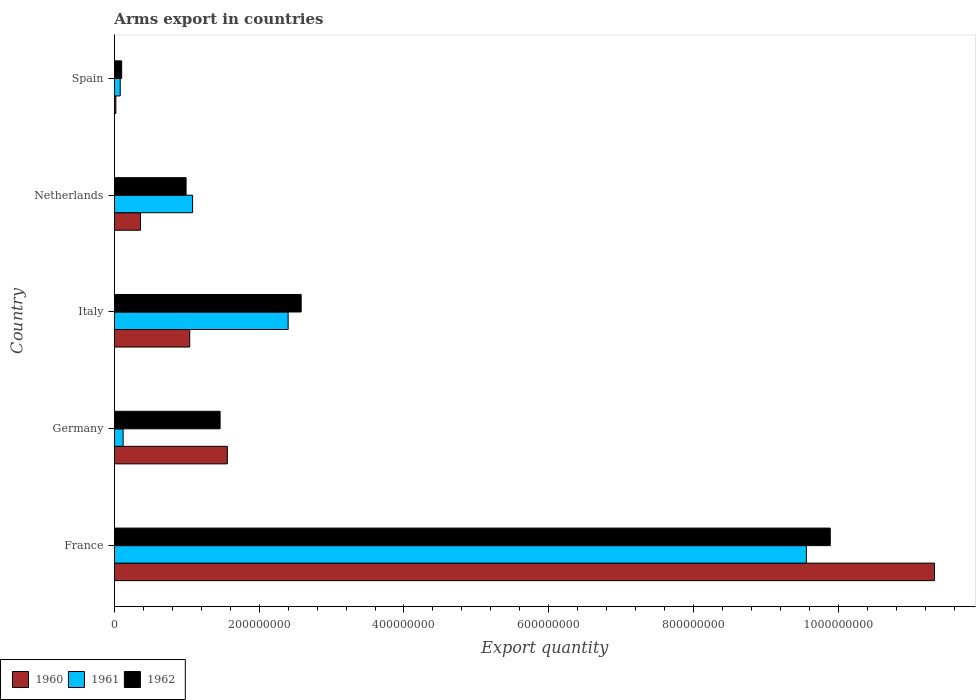How many groups of bars are there?
Give a very brief answer. 5. How many bars are there on the 1st tick from the top?
Provide a succinct answer. 3. How many bars are there on the 1st tick from the bottom?
Provide a succinct answer. 3. In how many cases, is the number of bars for a given country not equal to the number of legend labels?
Provide a short and direct response. 0. What is the total arms export in 1960 in Germany?
Your answer should be compact. 1.56e+08. Across all countries, what is the maximum total arms export in 1961?
Provide a short and direct response. 9.56e+08. In which country was the total arms export in 1960 maximum?
Ensure brevity in your answer.  France. What is the total total arms export in 1961 in the graph?
Offer a very short reply. 1.32e+09. What is the difference between the total arms export in 1961 in France and that in Spain?
Your answer should be compact. 9.48e+08. What is the difference between the total arms export in 1961 in Spain and the total arms export in 1960 in Netherlands?
Provide a succinct answer. -2.80e+07. What is the average total arms export in 1962 per country?
Provide a short and direct response. 3.00e+08. What is the difference between the total arms export in 1961 and total arms export in 1962 in France?
Provide a succinct answer. -3.30e+07. In how many countries, is the total arms export in 1960 greater than 840000000 ?
Your response must be concise. 1. What is the ratio of the total arms export in 1960 in Italy to that in Netherlands?
Your answer should be very brief. 2.89. Is the difference between the total arms export in 1961 in Germany and Spain greater than the difference between the total arms export in 1962 in Germany and Spain?
Offer a very short reply. No. What is the difference between the highest and the second highest total arms export in 1961?
Make the answer very short. 7.16e+08. What is the difference between the highest and the lowest total arms export in 1962?
Your answer should be compact. 9.79e+08. In how many countries, is the total arms export in 1962 greater than the average total arms export in 1962 taken over all countries?
Provide a short and direct response. 1. What does the 2nd bar from the bottom in Germany represents?
Keep it short and to the point. 1961. Is it the case that in every country, the sum of the total arms export in 1962 and total arms export in 1961 is greater than the total arms export in 1960?
Ensure brevity in your answer.  Yes. Are all the bars in the graph horizontal?
Your answer should be compact. Yes. What is the difference between two consecutive major ticks on the X-axis?
Provide a succinct answer. 2.00e+08. Are the values on the major ticks of X-axis written in scientific E-notation?
Keep it short and to the point. No. Where does the legend appear in the graph?
Your answer should be compact. Bottom left. What is the title of the graph?
Offer a very short reply. Arms export in countries. What is the label or title of the X-axis?
Keep it short and to the point. Export quantity. What is the label or title of the Y-axis?
Ensure brevity in your answer.  Country. What is the Export quantity in 1960 in France?
Offer a very short reply. 1.13e+09. What is the Export quantity of 1961 in France?
Make the answer very short. 9.56e+08. What is the Export quantity of 1962 in France?
Give a very brief answer. 9.89e+08. What is the Export quantity in 1960 in Germany?
Your response must be concise. 1.56e+08. What is the Export quantity in 1962 in Germany?
Provide a short and direct response. 1.46e+08. What is the Export quantity in 1960 in Italy?
Your answer should be compact. 1.04e+08. What is the Export quantity of 1961 in Italy?
Offer a terse response. 2.40e+08. What is the Export quantity of 1962 in Italy?
Provide a succinct answer. 2.58e+08. What is the Export quantity of 1960 in Netherlands?
Give a very brief answer. 3.60e+07. What is the Export quantity of 1961 in Netherlands?
Provide a succinct answer. 1.08e+08. What is the Export quantity of 1962 in Netherlands?
Give a very brief answer. 9.90e+07. What is the Export quantity in 1962 in Spain?
Your response must be concise. 1.00e+07. Across all countries, what is the maximum Export quantity of 1960?
Your response must be concise. 1.13e+09. Across all countries, what is the maximum Export quantity in 1961?
Give a very brief answer. 9.56e+08. Across all countries, what is the maximum Export quantity in 1962?
Give a very brief answer. 9.89e+08. Across all countries, what is the minimum Export quantity of 1960?
Your answer should be very brief. 2.00e+06. Across all countries, what is the minimum Export quantity in 1961?
Give a very brief answer. 8.00e+06. Across all countries, what is the minimum Export quantity of 1962?
Ensure brevity in your answer.  1.00e+07. What is the total Export quantity of 1960 in the graph?
Keep it short and to the point. 1.43e+09. What is the total Export quantity of 1961 in the graph?
Keep it short and to the point. 1.32e+09. What is the total Export quantity of 1962 in the graph?
Provide a short and direct response. 1.50e+09. What is the difference between the Export quantity in 1960 in France and that in Germany?
Give a very brief answer. 9.77e+08. What is the difference between the Export quantity in 1961 in France and that in Germany?
Give a very brief answer. 9.44e+08. What is the difference between the Export quantity in 1962 in France and that in Germany?
Ensure brevity in your answer.  8.43e+08. What is the difference between the Export quantity in 1960 in France and that in Italy?
Your answer should be very brief. 1.03e+09. What is the difference between the Export quantity in 1961 in France and that in Italy?
Your response must be concise. 7.16e+08. What is the difference between the Export quantity in 1962 in France and that in Italy?
Offer a terse response. 7.31e+08. What is the difference between the Export quantity of 1960 in France and that in Netherlands?
Offer a terse response. 1.10e+09. What is the difference between the Export quantity of 1961 in France and that in Netherlands?
Provide a short and direct response. 8.48e+08. What is the difference between the Export quantity of 1962 in France and that in Netherlands?
Your answer should be very brief. 8.90e+08. What is the difference between the Export quantity of 1960 in France and that in Spain?
Offer a very short reply. 1.13e+09. What is the difference between the Export quantity in 1961 in France and that in Spain?
Ensure brevity in your answer.  9.48e+08. What is the difference between the Export quantity in 1962 in France and that in Spain?
Your answer should be compact. 9.79e+08. What is the difference between the Export quantity in 1960 in Germany and that in Italy?
Keep it short and to the point. 5.20e+07. What is the difference between the Export quantity in 1961 in Germany and that in Italy?
Your answer should be very brief. -2.28e+08. What is the difference between the Export quantity in 1962 in Germany and that in Italy?
Offer a very short reply. -1.12e+08. What is the difference between the Export quantity in 1960 in Germany and that in Netherlands?
Offer a terse response. 1.20e+08. What is the difference between the Export quantity of 1961 in Germany and that in Netherlands?
Ensure brevity in your answer.  -9.60e+07. What is the difference between the Export quantity in 1962 in Germany and that in Netherlands?
Provide a succinct answer. 4.70e+07. What is the difference between the Export quantity of 1960 in Germany and that in Spain?
Provide a short and direct response. 1.54e+08. What is the difference between the Export quantity of 1961 in Germany and that in Spain?
Offer a very short reply. 4.00e+06. What is the difference between the Export quantity in 1962 in Germany and that in Spain?
Offer a terse response. 1.36e+08. What is the difference between the Export quantity of 1960 in Italy and that in Netherlands?
Offer a terse response. 6.80e+07. What is the difference between the Export quantity of 1961 in Italy and that in Netherlands?
Your response must be concise. 1.32e+08. What is the difference between the Export quantity of 1962 in Italy and that in Netherlands?
Your answer should be compact. 1.59e+08. What is the difference between the Export quantity in 1960 in Italy and that in Spain?
Keep it short and to the point. 1.02e+08. What is the difference between the Export quantity of 1961 in Italy and that in Spain?
Make the answer very short. 2.32e+08. What is the difference between the Export quantity in 1962 in Italy and that in Spain?
Your answer should be compact. 2.48e+08. What is the difference between the Export quantity in 1960 in Netherlands and that in Spain?
Make the answer very short. 3.40e+07. What is the difference between the Export quantity in 1962 in Netherlands and that in Spain?
Keep it short and to the point. 8.90e+07. What is the difference between the Export quantity in 1960 in France and the Export quantity in 1961 in Germany?
Ensure brevity in your answer.  1.12e+09. What is the difference between the Export quantity in 1960 in France and the Export quantity in 1962 in Germany?
Give a very brief answer. 9.87e+08. What is the difference between the Export quantity of 1961 in France and the Export quantity of 1962 in Germany?
Provide a short and direct response. 8.10e+08. What is the difference between the Export quantity in 1960 in France and the Export quantity in 1961 in Italy?
Provide a succinct answer. 8.93e+08. What is the difference between the Export quantity of 1960 in France and the Export quantity of 1962 in Italy?
Your response must be concise. 8.75e+08. What is the difference between the Export quantity in 1961 in France and the Export quantity in 1962 in Italy?
Keep it short and to the point. 6.98e+08. What is the difference between the Export quantity in 1960 in France and the Export quantity in 1961 in Netherlands?
Your answer should be very brief. 1.02e+09. What is the difference between the Export quantity of 1960 in France and the Export quantity of 1962 in Netherlands?
Provide a short and direct response. 1.03e+09. What is the difference between the Export quantity in 1961 in France and the Export quantity in 1962 in Netherlands?
Keep it short and to the point. 8.57e+08. What is the difference between the Export quantity in 1960 in France and the Export quantity in 1961 in Spain?
Offer a very short reply. 1.12e+09. What is the difference between the Export quantity in 1960 in France and the Export quantity in 1962 in Spain?
Offer a very short reply. 1.12e+09. What is the difference between the Export quantity of 1961 in France and the Export quantity of 1962 in Spain?
Give a very brief answer. 9.46e+08. What is the difference between the Export quantity in 1960 in Germany and the Export quantity in 1961 in Italy?
Provide a succinct answer. -8.40e+07. What is the difference between the Export quantity in 1960 in Germany and the Export quantity in 1962 in Italy?
Offer a terse response. -1.02e+08. What is the difference between the Export quantity in 1961 in Germany and the Export quantity in 1962 in Italy?
Keep it short and to the point. -2.46e+08. What is the difference between the Export quantity of 1960 in Germany and the Export quantity of 1961 in Netherlands?
Keep it short and to the point. 4.80e+07. What is the difference between the Export quantity of 1960 in Germany and the Export quantity of 1962 in Netherlands?
Your answer should be very brief. 5.70e+07. What is the difference between the Export quantity in 1961 in Germany and the Export quantity in 1962 in Netherlands?
Your response must be concise. -8.70e+07. What is the difference between the Export quantity of 1960 in Germany and the Export quantity of 1961 in Spain?
Keep it short and to the point. 1.48e+08. What is the difference between the Export quantity in 1960 in Germany and the Export quantity in 1962 in Spain?
Offer a terse response. 1.46e+08. What is the difference between the Export quantity of 1961 in Germany and the Export quantity of 1962 in Spain?
Give a very brief answer. 2.00e+06. What is the difference between the Export quantity in 1960 in Italy and the Export quantity in 1961 in Netherlands?
Provide a short and direct response. -4.00e+06. What is the difference between the Export quantity in 1961 in Italy and the Export quantity in 1962 in Netherlands?
Provide a short and direct response. 1.41e+08. What is the difference between the Export quantity of 1960 in Italy and the Export quantity of 1961 in Spain?
Ensure brevity in your answer.  9.60e+07. What is the difference between the Export quantity in 1960 in Italy and the Export quantity in 1962 in Spain?
Your answer should be compact. 9.40e+07. What is the difference between the Export quantity of 1961 in Italy and the Export quantity of 1962 in Spain?
Your response must be concise. 2.30e+08. What is the difference between the Export quantity in 1960 in Netherlands and the Export quantity in 1961 in Spain?
Give a very brief answer. 2.80e+07. What is the difference between the Export quantity of 1960 in Netherlands and the Export quantity of 1962 in Spain?
Your response must be concise. 2.60e+07. What is the difference between the Export quantity of 1961 in Netherlands and the Export quantity of 1962 in Spain?
Make the answer very short. 9.80e+07. What is the average Export quantity of 1960 per country?
Offer a terse response. 2.86e+08. What is the average Export quantity of 1961 per country?
Your response must be concise. 2.65e+08. What is the average Export quantity in 1962 per country?
Your answer should be compact. 3.00e+08. What is the difference between the Export quantity in 1960 and Export quantity in 1961 in France?
Give a very brief answer. 1.77e+08. What is the difference between the Export quantity in 1960 and Export quantity in 1962 in France?
Ensure brevity in your answer.  1.44e+08. What is the difference between the Export quantity in 1961 and Export quantity in 1962 in France?
Your answer should be very brief. -3.30e+07. What is the difference between the Export quantity of 1960 and Export quantity of 1961 in Germany?
Provide a succinct answer. 1.44e+08. What is the difference between the Export quantity of 1960 and Export quantity of 1962 in Germany?
Ensure brevity in your answer.  1.00e+07. What is the difference between the Export quantity of 1961 and Export quantity of 1962 in Germany?
Provide a short and direct response. -1.34e+08. What is the difference between the Export quantity of 1960 and Export quantity of 1961 in Italy?
Make the answer very short. -1.36e+08. What is the difference between the Export quantity of 1960 and Export quantity of 1962 in Italy?
Your answer should be compact. -1.54e+08. What is the difference between the Export quantity of 1961 and Export quantity of 1962 in Italy?
Make the answer very short. -1.80e+07. What is the difference between the Export quantity in 1960 and Export quantity in 1961 in Netherlands?
Provide a short and direct response. -7.20e+07. What is the difference between the Export quantity in 1960 and Export quantity in 1962 in Netherlands?
Your answer should be compact. -6.30e+07. What is the difference between the Export quantity of 1961 and Export quantity of 1962 in Netherlands?
Provide a short and direct response. 9.00e+06. What is the difference between the Export quantity of 1960 and Export quantity of 1961 in Spain?
Offer a very short reply. -6.00e+06. What is the difference between the Export quantity in 1960 and Export quantity in 1962 in Spain?
Offer a very short reply. -8.00e+06. What is the ratio of the Export quantity in 1960 in France to that in Germany?
Give a very brief answer. 7.26. What is the ratio of the Export quantity of 1961 in France to that in Germany?
Your answer should be compact. 79.67. What is the ratio of the Export quantity of 1962 in France to that in Germany?
Provide a short and direct response. 6.77. What is the ratio of the Export quantity in 1960 in France to that in Italy?
Your answer should be very brief. 10.89. What is the ratio of the Export quantity in 1961 in France to that in Italy?
Provide a short and direct response. 3.98. What is the ratio of the Export quantity of 1962 in France to that in Italy?
Ensure brevity in your answer.  3.83. What is the ratio of the Export quantity of 1960 in France to that in Netherlands?
Provide a succinct answer. 31.47. What is the ratio of the Export quantity in 1961 in France to that in Netherlands?
Provide a succinct answer. 8.85. What is the ratio of the Export quantity of 1962 in France to that in Netherlands?
Keep it short and to the point. 9.99. What is the ratio of the Export quantity of 1960 in France to that in Spain?
Your answer should be very brief. 566.5. What is the ratio of the Export quantity of 1961 in France to that in Spain?
Offer a very short reply. 119.5. What is the ratio of the Export quantity of 1962 in France to that in Spain?
Make the answer very short. 98.9. What is the ratio of the Export quantity in 1961 in Germany to that in Italy?
Offer a terse response. 0.05. What is the ratio of the Export quantity of 1962 in Germany to that in Italy?
Ensure brevity in your answer.  0.57. What is the ratio of the Export quantity in 1960 in Germany to that in Netherlands?
Your response must be concise. 4.33. What is the ratio of the Export quantity in 1962 in Germany to that in Netherlands?
Your response must be concise. 1.47. What is the ratio of the Export quantity of 1961 in Germany to that in Spain?
Your answer should be compact. 1.5. What is the ratio of the Export quantity in 1962 in Germany to that in Spain?
Offer a terse response. 14.6. What is the ratio of the Export quantity in 1960 in Italy to that in Netherlands?
Offer a terse response. 2.89. What is the ratio of the Export quantity of 1961 in Italy to that in Netherlands?
Ensure brevity in your answer.  2.22. What is the ratio of the Export quantity in 1962 in Italy to that in Netherlands?
Provide a succinct answer. 2.61. What is the ratio of the Export quantity in 1960 in Italy to that in Spain?
Your response must be concise. 52. What is the ratio of the Export quantity in 1962 in Italy to that in Spain?
Keep it short and to the point. 25.8. What is the ratio of the Export quantity of 1962 in Netherlands to that in Spain?
Ensure brevity in your answer.  9.9. What is the difference between the highest and the second highest Export quantity in 1960?
Provide a succinct answer. 9.77e+08. What is the difference between the highest and the second highest Export quantity of 1961?
Provide a short and direct response. 7.16e+08. What is the difference between the highest and the second highest Export quantity of 1962?
Keep it short and to the point. 7.31e+08. What is the difference between the highest and the lowest Export quantity in 1960?
Provide a succinct answer. 1.13e+09. What is the difference between the highest and the lowest Export quantity in 1961?
Provide a succinct answer. 9.48e+08. What is the difference between the highest and the lowest Export quantity in 1962?
Ensure brevity in your answer.  9.79e+08. 